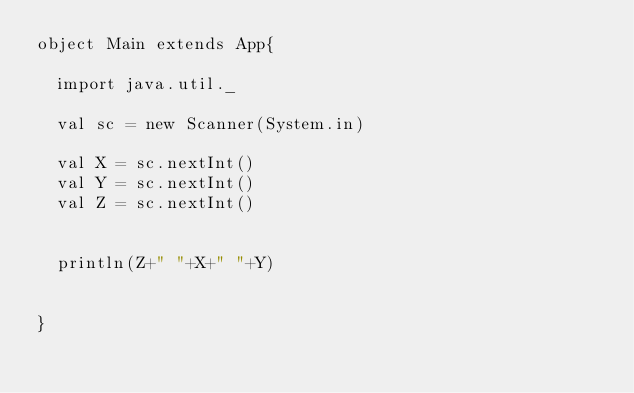Convert code to text. <code><loc_0><loc_0><loc_500><loc_500><_Scala_>object Main extends App{

  import java.util._

  val sc = new Scanner(System.in)

  val X = sc.nextInt()
  val Y = sc.nextInt()
  val Z = sc.nextInt()


  println(Z+" "+X+" "+Y)


}</code> 